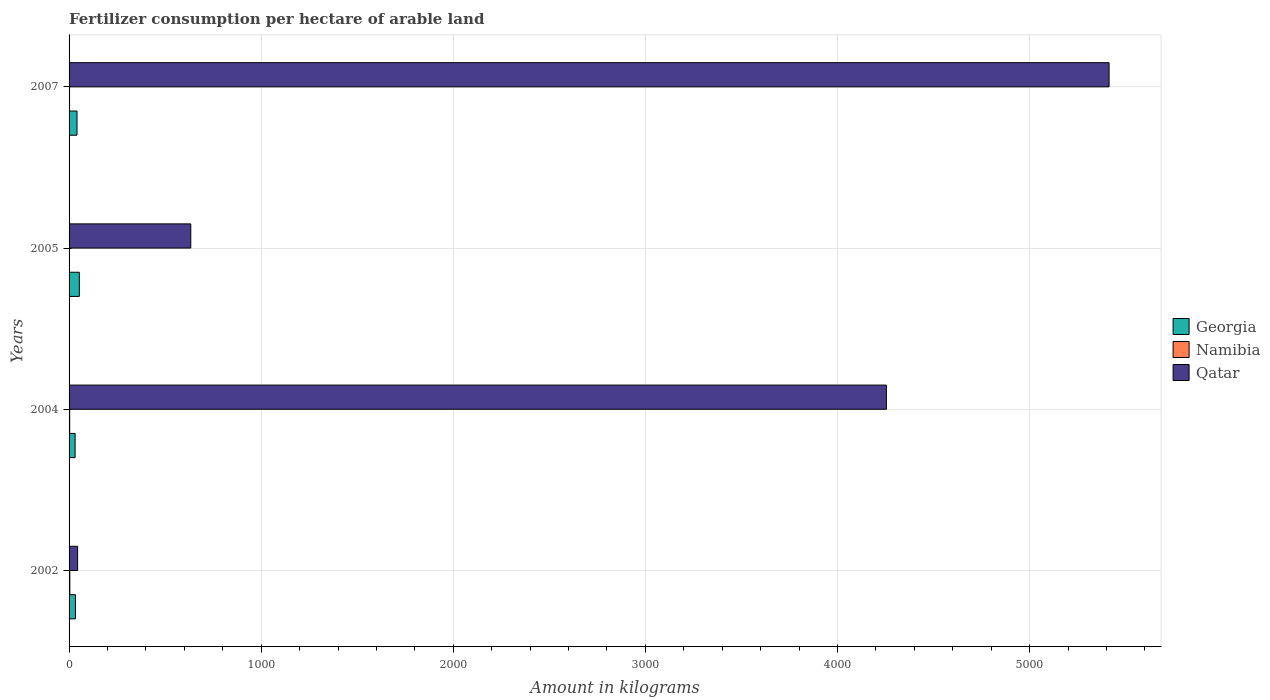Are the number of bars on each tick of the Y-axis equal?
Provide a short and direct response. Yes. What is the label of the 3rd group of bars from the top?
Make the answer very short. 2004. In how many cases, is the number of bars for a given year not equal to the number of legend labels?
Offer a terse response. 0. What is the amount of fertilizer consumption in Georgia in 2002?
Give a very brief answer. 33.04. Across all years, what is the maximum amount of fertilizer consumption in Namibia?
Your response must be concise. 3.9. Across all years, what is the minimum amount of fertilizer consumption in Georgia?
Your answer should be compact. 31.47. What is the total amount of fertilizer consumption in Qatar in the graph?
Ensure brevity in your answer.  1.03e+04. What is the difference between the amount of fertilizer consumption in Qatar in 2002 and that in 2007?
Provide a short and direct response. -5369.41. What is the difference between the amount of fertilizer consumption in Namibia in 2005 and the amount of fertilizer consumption in Qatar in 2002?
Make the answer very short. -42.52. What is the average amount of fertilizer consumption in Georgia per year?
Make the answer very short. 39.78. In the year 2007, what is the difference between the amount of fertilizer consumption in Georgia and amount of fertilizer consumption in Qatar?
Offer a very short reply. -5372.51. What is the ratio of the amount of fertilizer consumption in Qatar in 2002 to that in 2007?
Provide a succinct answer. 0.01. Is the difference between the amount of fertilizer consumption in Georgia in 2002 and 2005 greater than the difference between the amount of fertilizer consumption in Qatar in 2002 and 2005?
Keep it short and to the point. Yes. What is the difference between the highest and the second highest amount of fertilizer consumption in Georgia?
Provide a short and direct response. 11.95. What is the difference between the highest and the lowest amount of fertilizer consumption in Namibia?
Offer a terse response. 1.99. Is the sum of the amount of fertilizer consumption in Qatar in 2002 and 2004 greater than the maximum amount of fertilizer consumption in Georgia across all years?
Offer a terse response. Yes. What does the 2nd bar from the top in 2007 represents?
Offer a very short reply. Namibia. What does the 1st bar from the bottom in 2004 represents?
Give a very brief answer. Georgia. Is it the case that in every year, the sum of the amount of fertilizer consumption in Namibia and amount of fertilizer consumption in Qatar is greater than the amount of fertilizer consumption in Georgia?
Make the answer very short. Yes. How many bars are there?
Provide a succinct answer. 12. How many years are there in the graph?
Your answer should be very brief. 4. What is the difference between two consecutive major ticks on the X-axis?
Make the answer very short. 1000. Where does the legend appear in the graph?
Offer a very short reply. Center right. How many legend labels are there?
Keep it short and to the point. 3. What is the title of the graph?
Keep it short and to the point. Fertilizer consumption per hectare of arable land. Does "Yemen, Rep." appear as one of the legend labels in the graph?
Make the answer very short. No. What is the label or title of the X-axis?
Your response must be concise. Amount in kilograms. What is the label or title of the Y-axis?
Your answer should be compact. Years. What is the Amount in kilograms in Georgia in 2002?
Provide a succinct answer. 33.04. What is the Amount in kilograms of Namibia in 2002?
Ensure brevity in your answer.  3.9. What is the Amount in kilograms in Qatar in 2002?
Your answer should be very brief. 44.43. What is the Amount in kilograms of Georgia in 2004?
Your response must be concise. 31.47. What is the Amount in kilograms of Namibia in 2004?
Offer a very short reply. 3.2. What is the Amount in kilograms of Qatar in 2004?
Ensure brevity in your answer.  4254.57. What is the Amount in kilograms of Georgia in 2005?
Make the answer very short. 53.29. What is the Amount in kilograms in Namibia in 2005?
Provide a succinct answer. 1.91. What is the Amount in kilograms of Qatar in 2005?
Your answer should be compact. 633.53. What is the Amount in kilograms in Georgia in 2007?
Your answer should be very brief. 41.34. What is the Amount in kilograms in Namibia in 2007?
Your answer should be very brief. 2.46. What is the Amount in kilograms of Qatar in 2007?
Your answer should be compact. 5413.85. Across all years, what is the maximum Amount in kilograms in Georgia?
Your answer should be compact. 53.29. Across all years, what is the maximum Amount in kilograms of Namibia?
Provide a short and direct response. 3.9. Across all years, what is the maximum Amount in kilograms in Qatar?
Give a very brief answer. 5413.85. Across all years, what is the minimum Amount in kilograms of Georgia?
Your response must be concise. 31.47. Across all years, what is the minimum Amount in kilograms of Namibia?
Your answer should be compact. 1.91. Across all years, what is the minimum Amount in kilograms in Qatar?
Your response must be concise. 44.43. What is the total Amount in kilograms in Georgia in the graph?
Your answer should be very brief. 159.13. What is the total Amount in kilograms in Namibia in the graph?
Offer a very short reply. 11.48. What is the total Amount in kilograms in Qatar in the graph?
Offer a very short reply. 1.03e+04. What is the difference between the Amount in kilograms in Georgia in 2002 and that in 2004?
Your response must be concise. 1.57. What is the difference between the Amount in kilograms in Namibia in 2002 and that in 2004?
Make the answer very short. 0.7. What is the difference between the Amount in kilograms in Qatar in 2002 and that in 2004?
Your answer should be very brief. -4210.13. What is the difference between the Amount in kilograms of Georgia in 2002 and that in 2005?
Your response must be concise. -20.25. What is the difference between the Amount in kilograms of Namibia in 2002 and that in 2005?
Your answer should be very brief. 1.99. What is the difference between the Amount in kilograms of Qatar in 2002 and that in 2005?
Your answer should be very brief. -589.1. What is the difference between the Amount in kilograms of Georgia in 2002 and that in 2007?
Offer a very short reply. -8.3. What is the difference between the Amount in kilograms of Namibia in 2002 and that in 2007?
Give a very brief answer. 1.44. What is the difference between the Amount in kilograms of Qatar in 2002 and that in 2007?
Make the answer very short. -5369.41. What is the difference between the Amount in kilograms in Georgia in 2004 and that in 2005?
Keep it short and to the point. -21.82. What is the difference between the Amount in kilograms in Namibia in 2004 and that in 2005?
Keep it short and to the point. 1.29. What is the difference between the Amount in kilograms in Qatar in 2004 and that in 2005?
Your answer should be very brief. 3621.03. What is the difference between the Amount in kilograms in Georgia in 2004 and that in 2007?
Provide a short and direct response. -9.87. What is the difference between the Amount in kilograms of Namibia in 2004 and that in 2007?
Provide a short and direct response. 0.74. What is the difference between the Amount in kilograms of Qatar in 2004 and that in 2007?
Your response must be concise. -1159.28. What is the difference between the Amount in kilograms in Georgia in 2005 and that in 2007?
Provide a succinct answer. 11.95. What is the difference between the Amount in kilograms in Namibia in 2005 and that in 2007?
Your answer should be compact. -0.55. What is the difference between the Amount in kilograms of Qatar in 2005 and that in 2007?
Make the answer very short. -4780.31. What is the difference between the Amount in kilograms in Georgia in 2002 and the Amount in kilograms in Namibia in 2004?
Ensure brevity in your answer.  29.84. What is the difference between the Amount in kilograms in Georgia in 2002 and the Amount in kilograms in Qatar in 2004?
Ensure brevity in your answer.  -4221.53. What is the difference between the Amount in kilograms of Namibia in 2002 and the Amount in kilograms of Qatar in 2004?
Ensure brevity in your answer.  -4250.67. What is the difference between the Amount in kilograms of Georgia in 2002 and the Amount in kilograms of Namibia in 2005?
Your answer should be very brief. 31.13. What is the difference between the Amount in kilograms of Georgia in 2002 and the Amount in kilograms of Qatar in 2005?
Your response must be concise. -600.49. What is the difference between the Amount in kilograms in Namibia in 2002 and the Amount in kilograms in Qatar in 2005?
Offer a terse response. -629.63. What is the difference between the Amount in kilograms in Georgia in 2002 and the Amount in kilograms in Namibia in 2007?
Make the answer very short. 30.58. What is the difference between the Amount in kilograms of Georgia in 2002 and the Amount in kilograms of Qatar in 2007?
Your answer should be compact. -5380.8. What is the difference between the Amount in kilograms in Namibia in 2002 and the Amount in kilograms in Qatar in 2007?
Offer a very short reply. -5409.94. What is the difference between the Amount in kilograms of Georgia in 2004 and the Amount in kilograms of Namibia in 2005?
Keep it short and to the point. 29.56. What is the difference between the Amount in kilograms in Georgia in 2004 and the Amount in kilograms in Qatar in 2005?
Make the answer very short. -602.07. What is the difference between the Amount in kilograms in Namibia in 2004 and the Amount in kilograms in Qatar in 2005?
Keep it short and to the point. -630.33. What is the difference between the Amount in kilograms of Georgia in 2004 and the Amount in kilograms of Namibia in 2007?
Your response must be concise. 29. What is the difference between the Amount in kilograms of Georgia in 2004 and the Amount in kilograms of Qatar in 2007?
Your response must be concise. -5382.38. What is the difference between the Amount in kilograms in Namibia in 2004 and the Amount in kilograms in Qatar in 2007?
Offer a terse response. -5410.64. What is the difference between the Amount in kilograms of Georgia in 2005 and the Amount in kilograms of Namibia in 2007?
Make the answer very short. 50.82. What is the difference between the Amount in kilograms in Georgia in 2005 and the Amount in kilograms in Qatar in 2007?
Your response must be concise. -5360.56. What is the difference between the Amount in kilograms in Namibia in 2005 and the Amount in kilograms in Qatar in 2007?
Give a very brief answer. -5411.93. What is the average Amount in kilograms of Georgia per year?
Ensure brevity in your answer.  39.78. What is the average Amount in kilograms of Namibia per year?
Provide a succinct answer. 2.87. What is the average Amount in kilograms of Qatar per year?
Your answer should be very brief. 2586.6. In the year 2002, what is the difference between the Amount in kilograms in Georgia and Amount in kilograms in Namibia?
Provide a succinct answer. 29.14. In the year 2002, what is the difference between the Amount in kilograms in Georgia and Amount in kilograms in Qatar?
Provide a succinct answer. -11.39. In the year 2002, what is the difference between the Amount in kilograms of Namibia and Amount in kilograms of Qatar?
Your response must be concise. -40.53. In the year 2004, what is the difference between the Amount in kilograms of Georgia and Amount in kilograms of Namibia?
Provide a succinct answer. 28.26. In the year 2004, what is the difference between the Amount in kilograms in Georgia and Amount in kilograms in Qatar?
Your answer should be compact. -4223.1. In the year 2004, what is the difference between the Amount in kilograms in Namibia and Amount in kilograms in Qatar?
Your answer should be very brief. -4251.36. In the year 2005, what is the difference between the Amount in kilograms in Georgia and Amount in kilograms in Namibia?
Offer a terse response. 51.38. In the year 2005, what is the difference between the Amount in kilograms of Georgia and Amount in kilograms of Qatar?
Your answer should be compact. -580.25. In the year 2005, what is the difference between the Amount in kilograms of Namibia and Amount in kilograms of Qatar?
Make the answer very short. -631.62. In the year 2007, what is the difference between the Amount in kilograms in Georgia and Amount in kilograms in Namibia?
Your response must be concise. 38.87. In the year 2007, what is the difference between the Amount in kilograms in Georgia and Amount in kilograms in Qatar?
Your answer should be compact. -5372.51. In the year 2007, what is the difference between the Amount in kilograms of Namibia and Amount in kilograms of Qatar?
Offer a very short reply. -5411.38. What is the ratio of the Amount in kilograms in Georgia in 2002 to that in 2004?
Your answer should be compact. 1.05. What is the ratio of the Amount in kilograms in Namibia in 2002 to that in 2004?
Provide a succinct answer. 1.22. What is the ratio of the Amount in kilograms in Qatar in 2002 to that in 2004?
Provide a short and direct response. 0.01. What is the ratio of the Amount in kilograms of Georgia in 2002 to that in 2005?
Provide a succinct answer. 0.62. What is the ratio of the Amount in kilograms in Namibia in 2002 to that in 2005?
Provide a succinct answer. 2.04. What is the ratio of the Amount in kilograms of Qatar in 2002 to that in 2005?
Ensure brevity in your answer.  0.07. What is the ratio of the Amount in kilograms of Georgia in 2002 to that in 2007?
Ensure brevity in your answer.  0.8. What is the ratio of the Amount in kilograms in Namibia in 2002 to that in 2007?
Make the answer very short. 1.58. What is the ratio of the Amount in kilograms in Qatar in 2002 to that in 2007?
Provide a succinct answer. 0.01. What is the ratio of the Amount in kilograms in Georgia in 2004 to that in 2005?
Provide a succinct answer. 0.59. What is the ratio of the Amount in kilograms in Namibia in 2004 to that in 2005?
Offer a terse response. 1.68. What is the ratio of the Amount in kilograms of Qatar in 2004 to that in 2005?
Make the answer very short. 6.72. What is the ratio of the Amount in kilograms in Georgia in 2004 to that in 2007?
Your response must be concise. 0.76. What is the ratio of the Amount in kilograms in Namibia in 2004 to that in 2007?
Offer a terse response. 1.3. What is the ratio of the Amount in kilograms in Qatar in 2004 to that in 2007?
Provide a succinct answer. 0.79. What is the ratio of the Amount in kilograms of Georgia in 2005 to that in 2007?
Provide a short and direct response. 1.29. What is the ratio of the Amount in kilograms of Namibia in 2005 to that in 2007?
Give a very brief answer. 0.78. What is the ratio of the Amount in kilograms of Qatar in 2005 to that in 2007?
Your answer should be very brief. 0.12. What is the difference between the highest and the second highest Amount in kilograms of Georgia?
Your response must be concise. 11.95. What is the difference between the highest and the second highest Amount in kilograms in Namibia?
Provide a succinct answer. 0.7. What is the difference between the highest and the second highest Amount in kilograms in Qatar?
Ensure brevity in your answer.  1159.28. What is the difference between the highest and the lowest Amount in kilograms of Georgia?
Offer a very short reply. 21.82. What is the difference between the highest and the lowest Amount in kilograms in Namibia?
Offer a terse response. 1.99. What is the difference between the highest and the lowest Amount in kilograms in Qatar?
Your answer should be compact. 5369.41. 